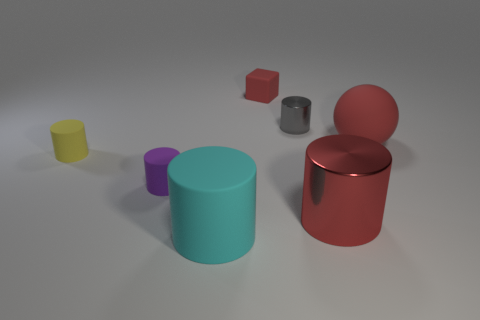Subtract all small metallic cylinders. How many cylinders are left? 4 Add 1 large red cylinders. How many objects exist? 8 Subtract all red cylinders. How many cylinders are left? 4 Subtract all cylinders. How many objects are left? 2 Add 7 cyan cylinders. How many cyan cylinders exist? 8 Subtract 0 blue cubes. How many objects are left? 7 Subtract 5 cylinders. How many cylinders are left? 0 Subtract all green cylinders. Subtract all blue cubes. How many cylinders are left? 5 Subtract all blue blocks. How many yellow cylinders are left? 1 Subtract all big gray cylinders. Subtract all cubes. How many objects are left? 6 